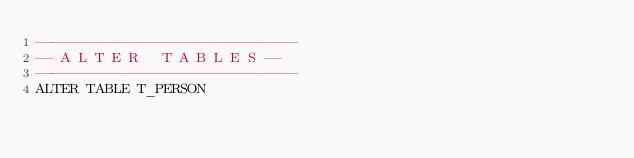Convert code to text. <code><loc_0><loc_0><loc_500><loc_500><_SQL_>-------------------------------
-- A L T E R   T A B L E S --
-------------------------------
ALTER TABLE T_PERSON</code> 